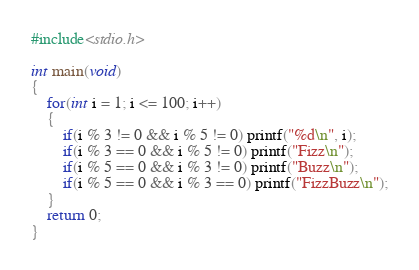Convert code to text. <code><loc_0><loc_0><loc_500><loc_500><_C_>#include<stdio.h>

int main(void)
{
    for(int i = 1; i <= 100; i++)
    {
        if(i % 3 != 0 && i % 5 != 0) printf("%d\n", i);
        if(i % 3 == 0 && i % 5 != 0) printf("Fizz\n");
        if(i % 5 == 0 && i % 3 != 0) printf("Buzz\n");
        if(i % 5 == 0 && i % 3 == 0) printf("FizzBuzz\n");
    }
    return 0;
}</code> 